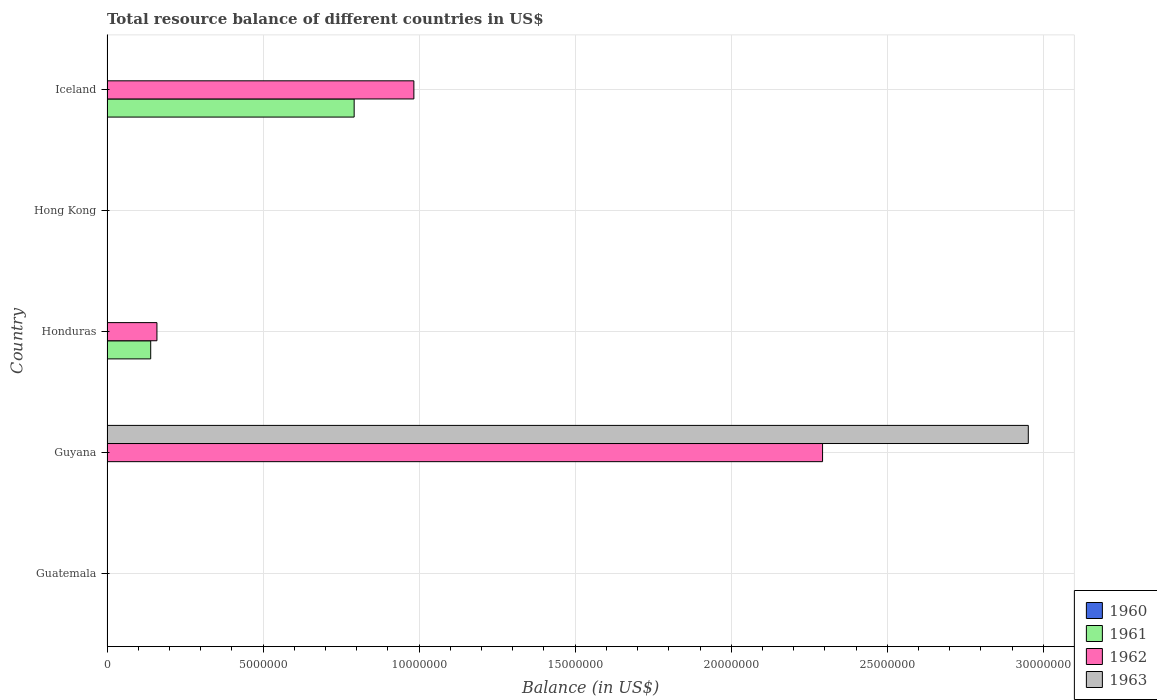How many different coloured bars are there?
Make the answer very short. 3. What is the label of the 5th group of bars from the top?
Your response must be concise. Guatemala. Across all countries, what is the maximum total resource balance in 1962?
Provide a succinct answer. 2.29e+07. Across all countries, what is the minimum total resource balance in 1960?
Keep it short and to the point. 0. In which country was the total resource balance in 1961 maximum?
Your answer should be very brief. Iceland. What is the total total resource balance in 1960 in the graph?
Provide a short and direct response. 0. What is the difference between the total resource balance in 1961 in Honduras and that in Iceland?
Offer a terse response. -6.52e+06. What is the difference between the total resource balance in 1961 in Guyana and the total resource balance in 1963 in Hong Kong?
Your answer should be very brief. 0. What is the average total resource balance in 1961 per country?
Offer a terse response. 1.86e+06. What is the difference between the highest and the second highest total resource balance in 1962?
Keep it short and to the point. 1.31e+07. What is the difference between the highest and the lowest total resource balance in 1962?
Provide a succinct answer. 2.29e+07. Is the sum of the total resource balance in 1962 in Honduras and Iceland greater than the maximum total resource balance in 1961 across all countries?
Your response must be concise. Yes. Is it the case that in every country, the sum of the total resource balance in 1962 and total resource balance in 1961 is greater than the total resource balance in 1960?
Offer a very short reply. No. Are all the bars in the graph horizontal?
Ensure brevity in your answer.  Yes. How many countries are there in the graph?
Your response must be concise. 5. What is the difference between two consecutive major ticks on the X-axis?
Offer a very short reply. 5.00e+06. Are the values on the major ticks of X-axis written in scientific E-notation?
Offer a very short reply. No. Where does the legend appear in the graph?
Ensure brevity in your answer.  Bottom right. How many legend labels are there?
Ensure brevity in your answer.  4. What is the title of the graph?
Your answer should be compact. Total resource balance of different countries in US$. Does "1984" appear as one of the legend labels in the graph?
Make the answer very short. No. What is the label or title of the X-axis?
Your answer should be very brief. Balance (in US$). What is the label or title of the Y-axis?
Offer a terse response. Country. What is the Balance (in US$) of 1960 in Guatemala?
Your response must be concise. 0. What is the Balance (in US$) of 1961 in Guatemala?
Ensure brevity in your answer.  0. What is the Balance (in US$) in 1963 in Guatemala?
Offer a terse response. 0. What is the Balance (in US$) of 1961 in Guyana?
Offer a terse response. 0. What is the Balance (in US$) of 1962 in Guyana?
Make the answer very short. 2.29e+07. What is the Balance (in US$) in 1963 in Guyana?
Your answer should be very brief. 2.95e+07. What is the Balance (in US$) in 1960 in Honduras?
Your answer should be very brief. 0. What is the Balance (in US$) in 1961 in Honduras?
Provide a short and direct response. 1.40e+06. What is the Balance (in US$) of 1962 in Honduras?
Provide a short and direct response. 1.60e+06. What is the Balance (in US$) of 1961 in Hong Kong?
Offer a very short reply. 0. What is the Balance (in US$) of 1962 in Hong Kong?
Your response must be concise. 0. What is the Balance (in US$) in 1963 in Hong Kong?
Your response must be concise. 0. What is the Balance (in US$) of 1960 in Iceland?
Provide a succinct answer. 0. What is the Balance (in US$) in 1961 in Iceland?
Keep it short and to the point. 7.92e+06. What is the Balance (in US$) in 1962 in Iceland?
Provide a succinct answer. 9.83e+06. What is the Balance (in US$) of 1963 in Iceland?
Give a very brief answer. 0. Across all countries, what is the maximum Balance (in US$) in 1961?
Make the answer very short. 7.92e+06. Across all countries, what is the maximum Balance (in US$) of 1962?
Provide a short and direct response. 2.29e+07. Across all countries, what is the maximum Balance (in US$) of 1963?
Offer a very short reply. 2.95e+07. Across all countries, what is the minimum Balance (in US$) in 1962?
Give a very brief answer. 0. Across all countries, what is the minimum Balance (in US$) in 1963?
Provide a short and direct response. 0. What is the total Balance (in US$) of 1960 in the graph?
Provide a succinct answer. 0. What is the total Balance (in US$) in 1961 in the graph?
Provide a succinct answer. 9.32e+06. What is the total Balance (in US$) of 1962 in the graph?
Give a very brief answer. 3.44e+07. What is the total Balance (in US$) in 1963 in the graph?
Ensure brevity in your answer.  2.95e+07. What is the difference between the Balance (in US$) in 1962 in Guyana and that in Honduras?
Offer a very short reply. 2.13e+07. What is the difference between the Balance (in US$) of 1962 in Guyana and that in Iceland?
Give a very brief answer. 1.31e+07. What is the difference between the Balance (in US$) of 1961 in Honduras and that in Iceland?
Provide a succinct answer. -6.52e+06. What is the difference between the Balance (in US$) of 1962 in Honduras and that in Iceland?
Offer a very short reply. -8.23e+06. What is the difference between the Balance (in US$) of 1961 in Honduras and the Balance (in US$) of 1962 in Iceland?
Offer a very short reply. -8.43e+06. What is the average Balance (in US$) of 1961 per country?
Give a very brief answer. 1.86e+06. What is the average Balance (in US$) in 1962 per country?
Provide a succinct answer. 6.87e+06. What is the average Balance (in US$) of 1963 per country?
Offer a very short reply. 5.90e+06. What is the difference between the Balance (in US$) of 1962 and Balance (in US$) of 1963 in Guyana?
Your answer should be compact. -6.59e+06. What is the difference between the Balance (in US$) of 1961 and Balance (in US$) of 1962 in Honduras?
Your response must be concise. -2.00e+05. What is the difference between the Balance (in US$) in 1961 and Balance (in US$) in 1962 in Iceland?
Your answer should be compact. -1.91e+06. What is the ratio of the Balance (in US$) in 1962 in Guyana to that in Honduras?
Make the answer very short. 14.33. What is the ratio of the Balance (in US$) of 1962 in Guyana to that in Iceland?
Your answer should be compact. 2.33. What is the ratio of the Balance (in US$) in 1961 in Honduras to that in Iceland?
Give a very brief answer. 0.18. What is the ratio of the Balance (in US$) in 1962 in Honduras to that in Iceland?
Give a very brief answer. 0.16. What is the difference between the highest and the second highest Balance (in US$) in 1962?
Make the answer very short. 1.31e+07. What is the difference between the highest and the lowest Balance (in US$) in 1961?
Your response must be concise. 7.92e+06. What is the difference between the highest and the lowest Balance (in US$) of 1962?
Offer a terse response. 2.29e+07. What is the difference between the highest and the lowest Balance (in US$) of 1963?
Give a very brief answer. 2.95e+07. 